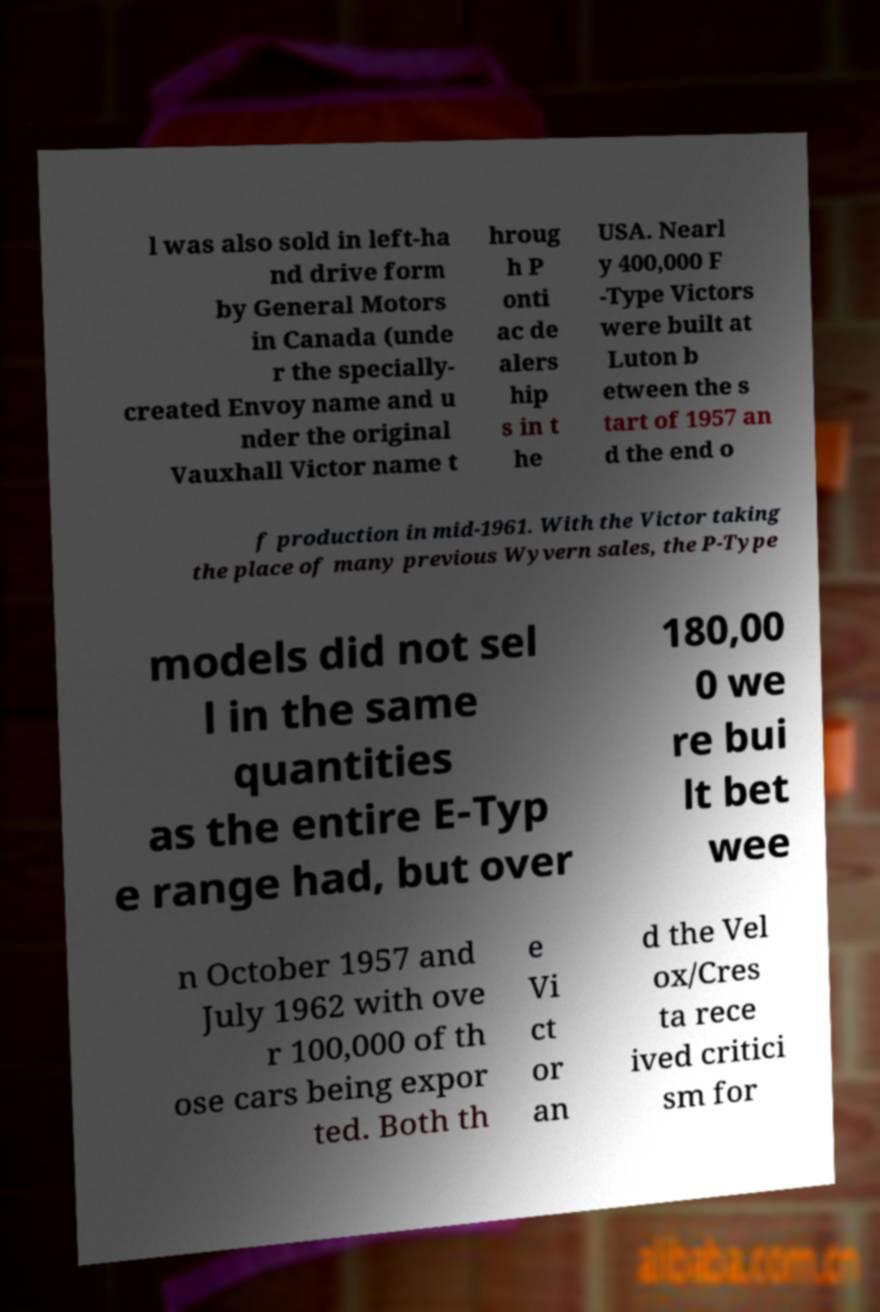There's text embedded in this image that I need extracted. Can you transcribe it verbatim? l was also sold in left-ha nd drive form by General Motors in Canada (unde r the specially- created Envoy name and u nder the original Vauxhall Victor name t hroug h P onti ac de alers hip s in t he USA. Nearl y 400,000 F -Type Victors were built at Luton b etween the s tart of 1957 an d the end o f production in mid-1961. With the Victor taking the place of many previous Wyvern sales, the P-Type models did not sel l in the same quantities as the entire E-Typ e range had, but over 180,00 0 we re bui lt bet wee n October 1957 and July 1962 with ove r 100,000 of th ose cars being expor ted. Both th e Vi ct or an d the Vel ox/Cres ta rece ived critici sm for 